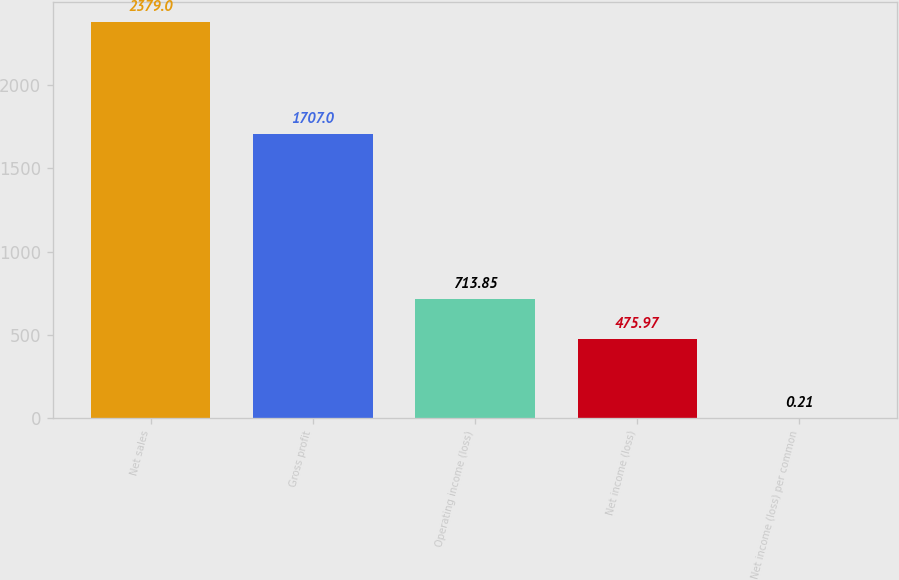Convert chart. <chart><loc_0><loc_0><loc_500><loc_500><bar_chart><fcel>Net sales<fcel>Gross profit<fcel>Operating income (loss)<fcel>Net income (loss)<fcel>Net income (loss) per common<nl><fcel>2379<fcel>1707<fcel>713.85<fcel>475.97<fcel>0.21<nl></chart> 